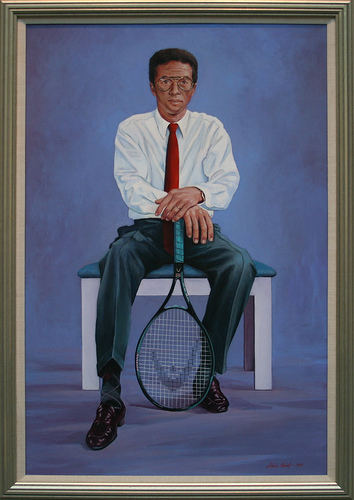Please provide a short description for this region: [0.37, 0.09, 0.63, 0.46]. The man is wearing a white shirt. 